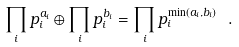<formula> <loc_0><loc_0><loc_500><loc_500>\prod _ { i } p _ { i } ^ { a _ { i } } \oplus \prod _ { i } p _ { i } ^ { b _ { i } } = \prod _ { i } p _ { i } ^ { \min ( a _ { i } , b _ { i } ) } \ .</formula> 